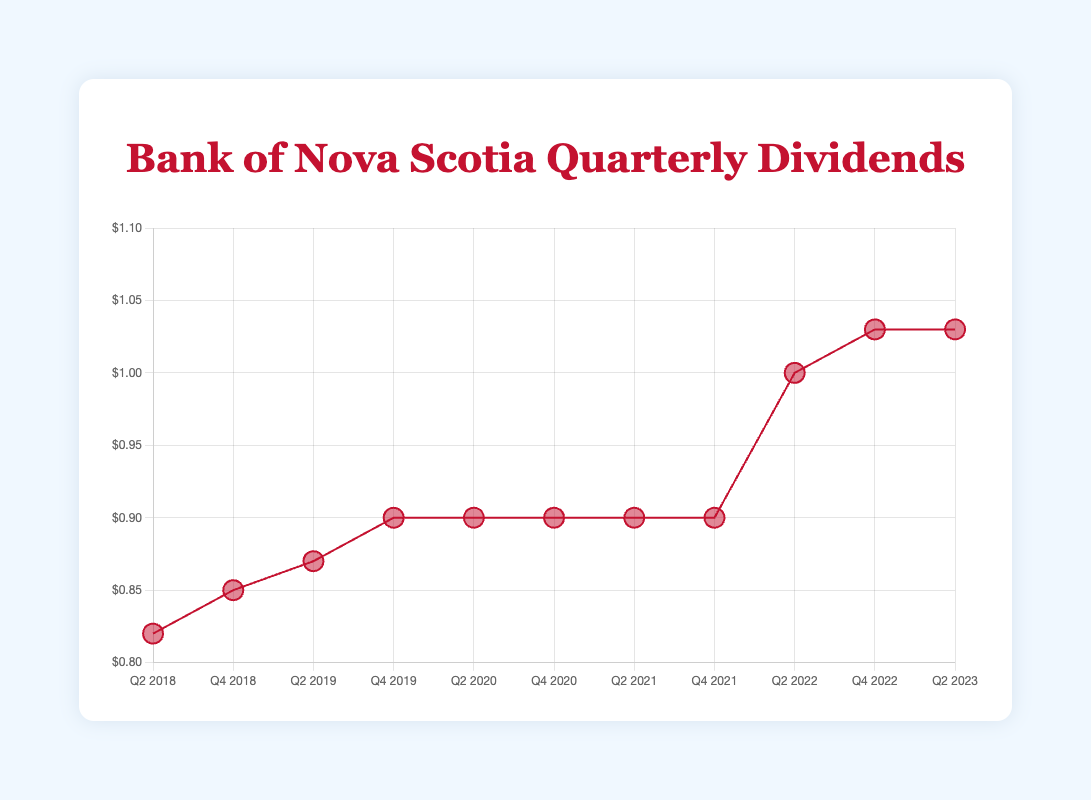What's the title of the chart? The title can be found at the top of the figure in large, bold text. It reads "Bank of Nova Scotia Quarterly Dividends".
Answer: Bank of Nova Scotia Quarterly Dividends What is the highest dividend payout recorded on the chart? By visually scanning the plot and the y-axis, it is evident that the highest dividend is $1.03, which appears in both Q4 2022 and Q2 2023.
Answer: $1.03 How many distinct quarters are displayed in the chart? The x-axis shows labels for each quarter. Counting these labels gives a total of 11 quarters.
Answer: 11 By how much did the dividend increase from Q4 2018 to Q4 2019? The dividend in Q4 2018 is $0.85 and in Q4 2019 is $0.90. The increase is calculated as $0.90 - $0.85.
Answer: $0.05 What was the dividend payout in Q2 2021? Locate Q2 2021 on the x-axis and check its corresponding point on the plot. This point indicates a dividend of $0.90.
Answer: $0.90 did the dividend stay the same for three consecutive quarters? If so, which ones? Look across the plot to see if any three consecutive points are aligned at the same value. From Q2 2020 to Q4 2021, the dividend stayed constant at $0.90.
Answer: Q2 2020 to Q4 2021 On which date did the dividend first reach $1.00? The plot shows the first instance where the dividend crosses the $1.00 threshold, which is in Q2 2022.
Answer: Q2 2022 What is the average dividend payout over the five-year period (11 data points)? To find the average, sum all dividend values: (0.82 + 0.85 + 0.87 + 0.90 + 0.90 + 0.90 + 0.90 + 0.90 + 1.00 + 1.03 + 1.03) = 10.00. Divide by 11 (10.00 / 11).
Answer: $0.91 What was the total increase in dividends from Q2 2018 to Q2 2023? The dividend in Q2 2018 is $0.82, and in Q2 2023, it is $1.03. The total increase is $1.03 - $0.82.
Answer: $0.21 